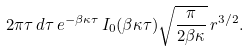Convert formula to latex. <formula><loc_0><loc_0><loc_500><loc_500>2 \pi \tau \, d \tau \, e ^ { - \beta \kappa \tau } \, I _ { 0 } ( \beta \kappa \tau ) \sqrt { \frac { \pi } { 2 \beta \kappa } } \, r ^ { 3 / 2 } .</formula> 